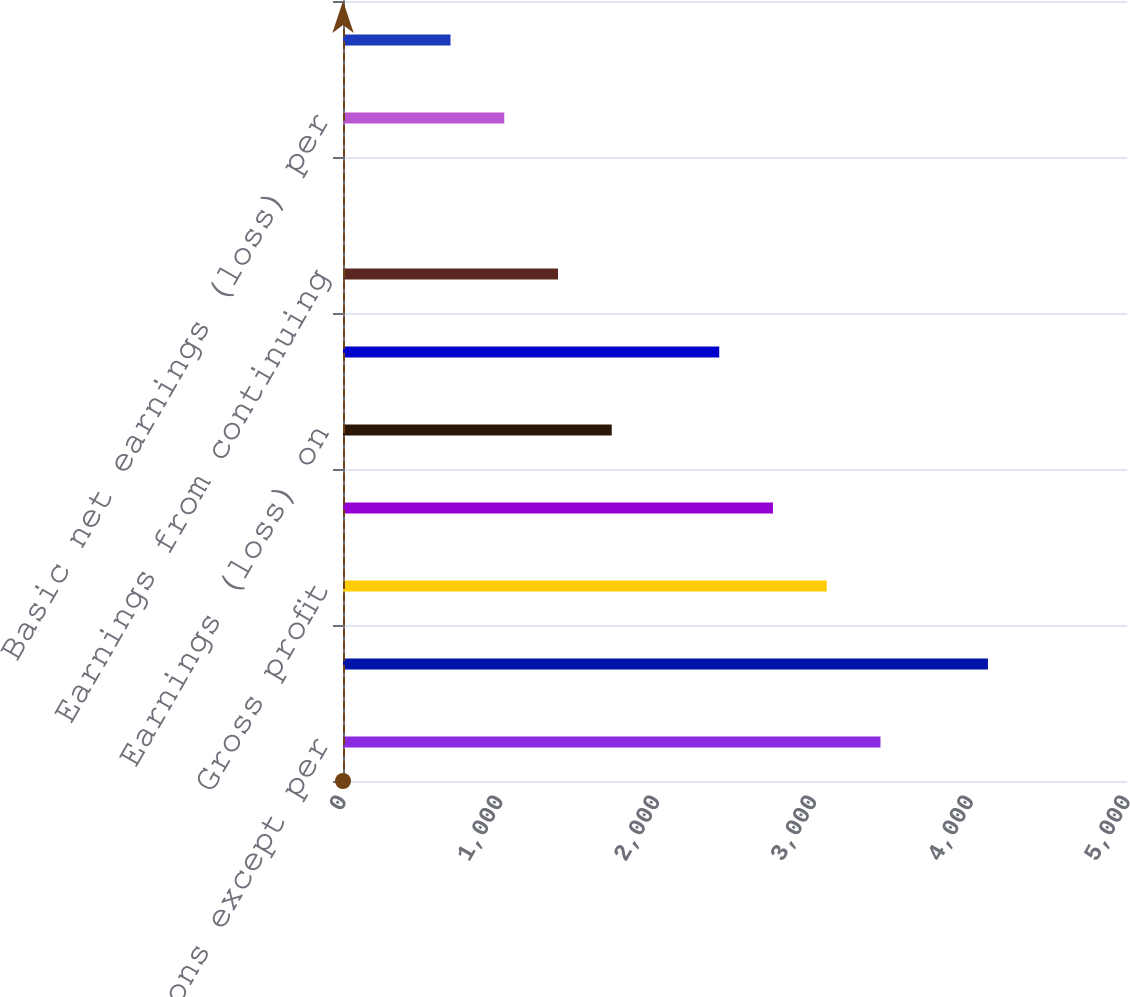<chart> <loc_0><loc_0><loc_500><loc_500><bar_chart><fcel>Amounts in millions except per<fcel>Net sales<fcel>Gross profit<fcel>Earnings (loss) from<fcel>Earnings (loss) on<fcel>Net earnings (loss)<fcel>Earnings from continuing<fcel>Discontinued operations<fcel>Basic net earnings (loss) per<fcel>Diluted net earnings (loss)<nl><fcel>3427.8<fcel>4113.34<fcel>3085.03<fcel>2742.26<fcel>1713.95<fcel>2399.49<fcel>1371.18<fcel>0.1<fcel>1028.41<fcel>685.64<nl></chart> 